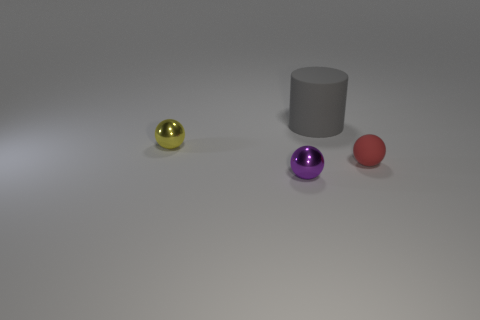If the gray cylinder were to roll towards the camera, which sphere would it likely make contact with first? If the gray cylinder were to roll towards the camera, it seems it would make contact with the larger red sphere first, based on their relative positions in the image. 